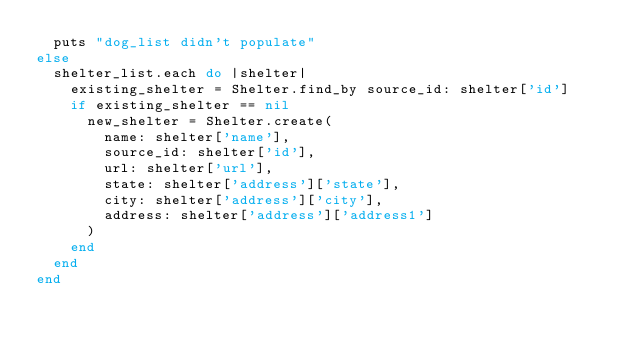Convert code to text. <code><loc_0><loc_0><loc_500><loc_500><_Ruby_>  puts "dog_list didn't populate"
else
  shelter_list.each do |shelter|
    existing_shelter = Shelter.find_by source_id: shelter['id']
    if existing_shelter == nil
      new_shelter = Shelter.create(
        name: shelter['name'],
        source_id: shelter['id'],
        url: shelter['url'],
        state: shelter['address']['state'],
        city: shelter['address']['city'],
        address: shelter['address']['address1']
      )
    end
  end
end
</code> 